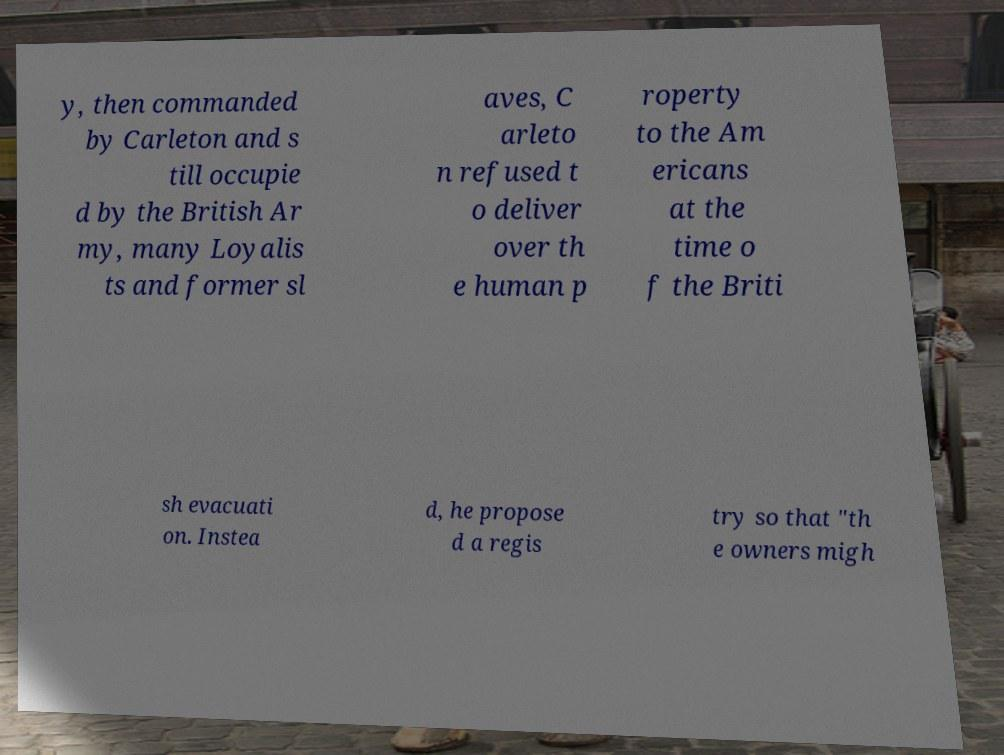Can you accurately transcribe the text from the provided image for me? y, then commanded by Carleton and s till occupie d by the British Ar my, many Loyalis ts and former sl aves, C arleto n refused t o deliver over th e human p roperty to the Am ericans at the time o f the Briti sh evacuati on. Instea d, he propose d a regis try so that "th e owners migh 